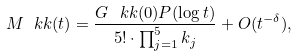Convert formula to latex. <formula><loc_0><loc_0><loc_500><loc_500>M _ { \ } k k ( t ) = \frac { G _ { \ } k k ( 0 ) P ( \log t ) } { 5 ! \cdot \prod _ { j = 1 } ^ { 5 } k _ { j } } + O ( t ^ { - \delta } ) ,</formula> 